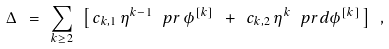Convert formula to latex. <formula><loc_0><loc_0><loc_500><loc_500>\Delta \ = \ \sum _ { k \geq 2 } \ \left [ \, c _ { k , 1 } \, \eta ^ { k - 1 } \, \ p r \, \phi ^ { [ k ] } \ + \ c _ { k , 2 } \, \eta ^ { k } \, \ p r d \phi ^ { [ k ] } \, \right ] \ ,</formula> 